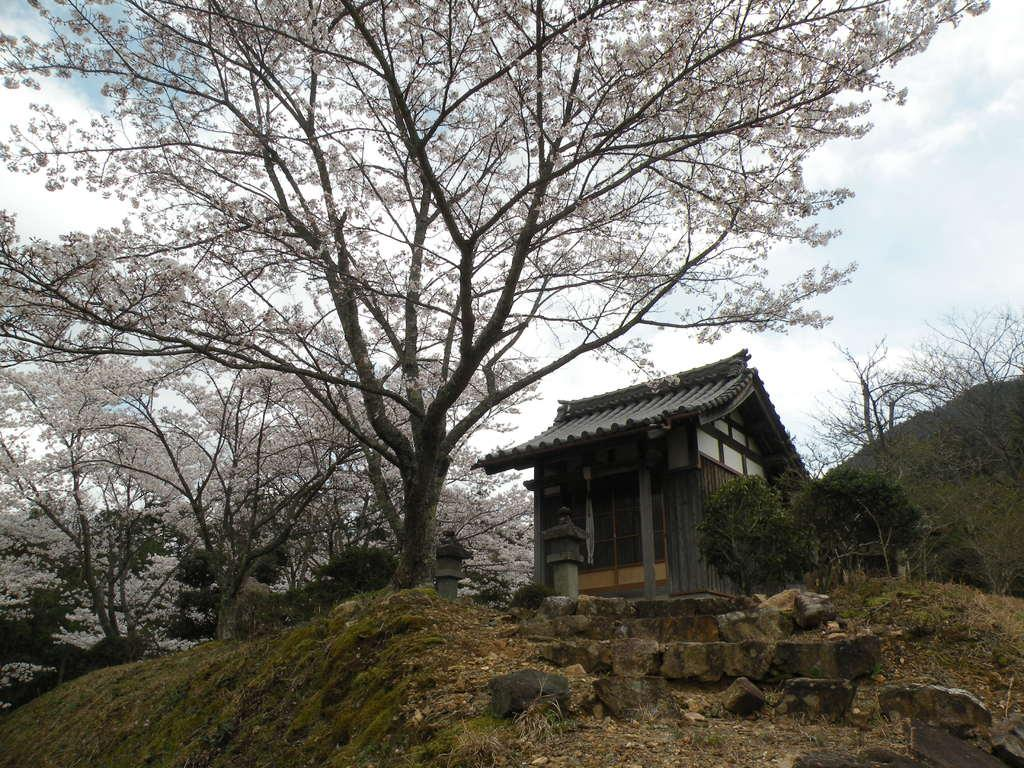What type of structure is present in the image? There is a house in the image. What kind of vegetation can be seen in the image? There are trees with flowers and plants in the image. What is located in front of the house? There are stones in front of the house. What is visible at the top of the image? The sky is visible at the top of the image. What type of business is being conducted in the image? There is no indication of a business being conducted in the image; it primarily features a house, trees, plants, stones, and the sky. 